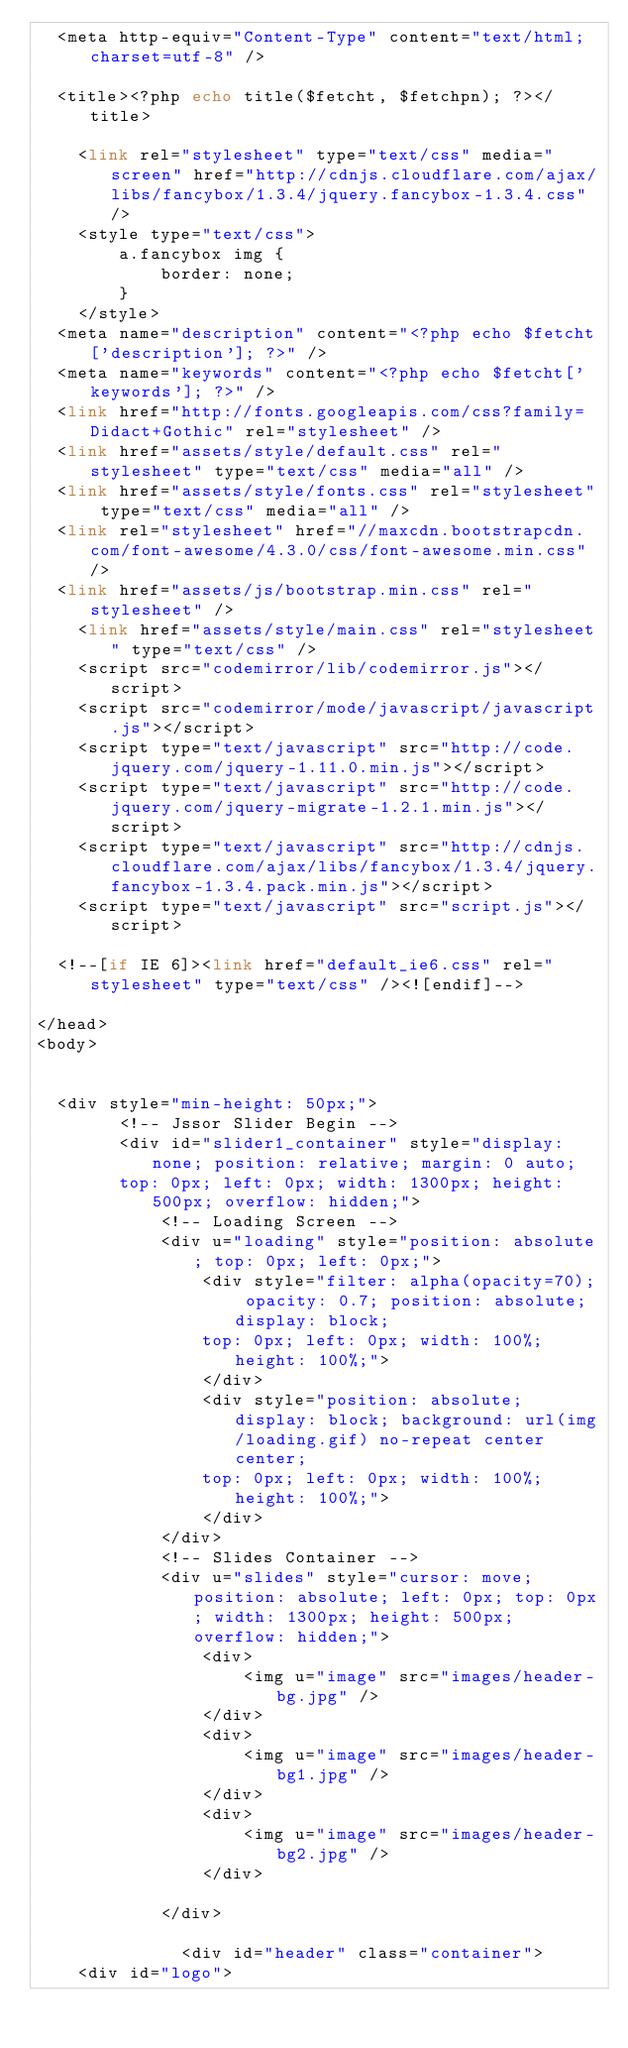<code> <loc_0><loc_0><loc_500><loc_500><_PHP_>	<meta http-equiv="Content-Type" content="text/html; charset=utf-8" />
    
	<title><?php echo title($fetcht, $fetchpn); ?></title>
    
    <link rel="stylesheet" type="text/css" media="screen" href="http://cdnjs.cloudflare.com/ajax/libs/fancybox/1.3.4/jquery.fancybox-1.3.4.css" />
    <style type="text/css">
        a.fancybox img {
            border: none;
        } 
    </style>
	<meta name="description" content="<?php echo $fetcht['description']; ?>" />
	<meta name="keywords" content="<?php echo $fetcht['keywords']; ?>" />
	<link href="http://fonts.googleapis.com/css?family=Didact+Gothic" rel="stylesheet" />
	<link href="assets/style/default.css" rel="stylesheet" type="text/css" media="all" />
	<link href="assets/style/fonts.css" rel="stylesheet" type="text/css" media="all" />
	<link rel="stylesheet" href="//maxcdn.bootstrapcdn.com/font-awesome/4.3.0/css/font-awesome.min.css" />
	<link href="assets/js/bootstrap.min.css" rel="stylesheet" />
    <link href="assets/style/main.css" rel="stylesheet" type="text/css" />
    <script src="codemirror/lib/codemirror.js"></script>
    <script src="codemirror/mode/javascript/javascript.js"></script>
    <script type="text/javascript" src="http://code.jquery.com/jquery-1.11.0.min.js"></script>
    <script type="text/javascript" src="http://code.jquery.com/jquery-migrate-1.2.1.min.js"></script>
    <script type="text/javascript" src="http://cdnjs.cloudflare.com/ajax/libs/fancybox/1.3.4/jquery.fancybox-1.3.4.pack.min.js"></script>
    <script type="text/javascript" src="script.js"></script>

	<!--[if IE 6]><link href="default_ie6.css" rel="stylesheet" type="text/css" /><![endif]-->
	
</head>
<body>


	<div style="min-height: 50px;">
        <!-- Jssor Slider Begin -->
        <div id="slider1_container" style="display: none; position: relative; margin: 0 auto;
        top: 0px; left: 0px; width: 1300px; height: 500px; overflow: hidden;">
            <!-- Loading Screen -->
            <div u="loading" style="position: absolute; top: 0px; left: 0px;">
                <div style="filter: alpha(opacity=70); opacity: 0.7; position: absolute; display: block;
                top: 0px; left: 0px; width: 100%; height: 100%;">
                </div>
                <div style="position: absolute; display: block; background: url(img/loading.gif) no-repeat center center;
                top: 0px; left: 0px; width: 100%; height: 100%;">
                </div>
            </div>
            <!-- Slides Container -->
            <div u="slides" style="cursor: move; position: absolute; left: 0px; top: 0px; width: 1300px; height: 500px; overflow: hidden;">
                <div>
                    <img u="image" src="images/header-bg.jpg" />
                </div>
                <div>
                    <img u="image" src="images/header-bg1.jpg" />
                </div>
                <div>
                    <img u="image" src="images/header-bg2.jpg" />
                </div>
				
            </div>
			
            	<div id="header" class="container">
		<div id="logo"></code> 